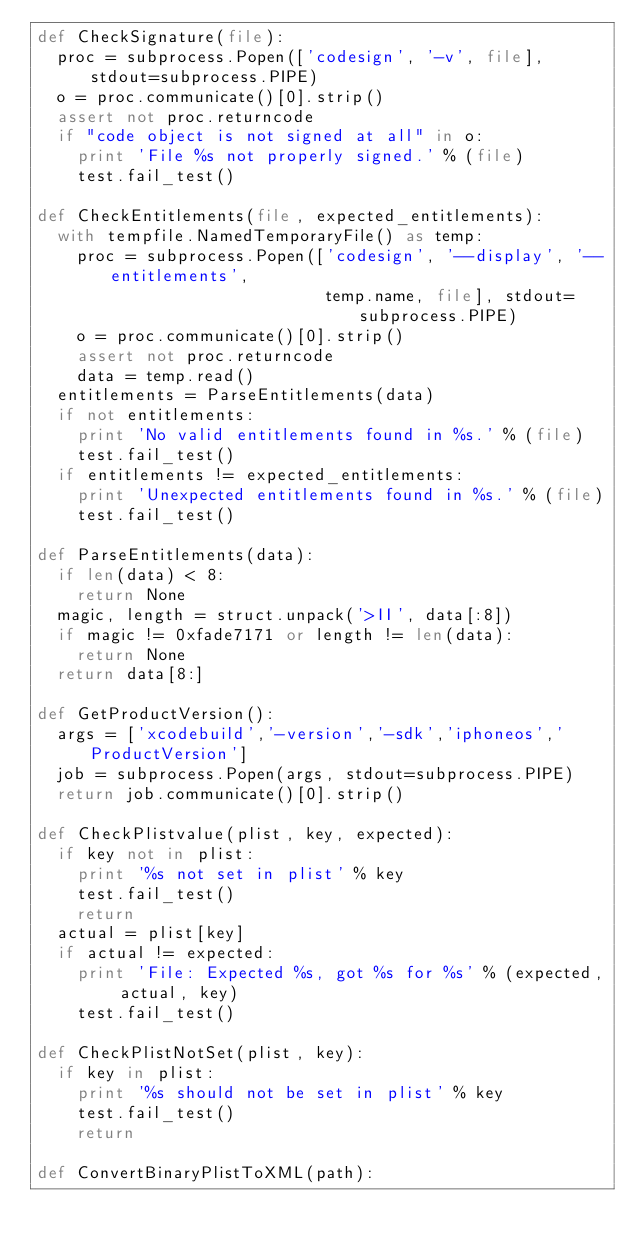Convert code to text. <code><loc_0><loc_0><loc_500><loc_500><_Python_>def CheckSignature(file):
  proc = subprocess.Popen(['codesign', '-v', file], stdout=subprocess.PIPE)
  o = proc.communicate()[0].strip()
  assert not proc.returncode
  if "code object is not signed at all" in o:
    print 'File %s not properly signed.' % (file)
    test.fail_test()

def CheckEntitlements(file, expected_entitlements):
  with tempfile.NamedTemporaryFile() as temp:
    proc = subprocess.Popen(['codesign', '--display', '--entitlements',
                             temp.name, file], stdout=subprocess.PIPE)
    o = proc.communicate()[0].strip()
    assert not proc.returncode
    data = temp.read()
  entitlements = ParseEntitlements(data)
  if not entitlements:
    print 'No valid entitlements found in %s.' % (file)
    test.fail_test()
  if entitlements != expected_entitlements:
    print 'Unexpected entitlements found in %s.' % (file)
    test.fail_test()

def ParseEntitlements(data):
  if len(data) < 8:
    return None
  magic, length = struct.unpack('>II', data[:8])
  if magic != 0xfade7171 or length != len(data):
    return None
  return data[8:]

def GetProductVersion():
  args = ['xcodebuild','-version','-sdk','iphoneos','ProductVersion']
  job = subprocess.Popen(args, stdout=subprocess.PIPE)
  return job.communicate()[0].strip()

def CheckPlistvalue(plist, key, expected):
  if key not in plist:
    print '%s not set in plist' % key
    test.fail_test()
    return
  actual = plist[key]
  if actual != expected:
    print 'File: Expected %s, got %s for %s' % (expected, actual, key)
    test.fail_test()

def CheckPlistNotSet(plist, key):
  if key in plist:
    print '%s should not be set in plist' % key
    test.fail_test()
    return

def ConvertBinaryPlistToXML(path):</code> 